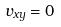Convert formula to latex. <formula><loc_0><loc_0><loc_500><loc_500>v _ { x y } = 0</formula> 